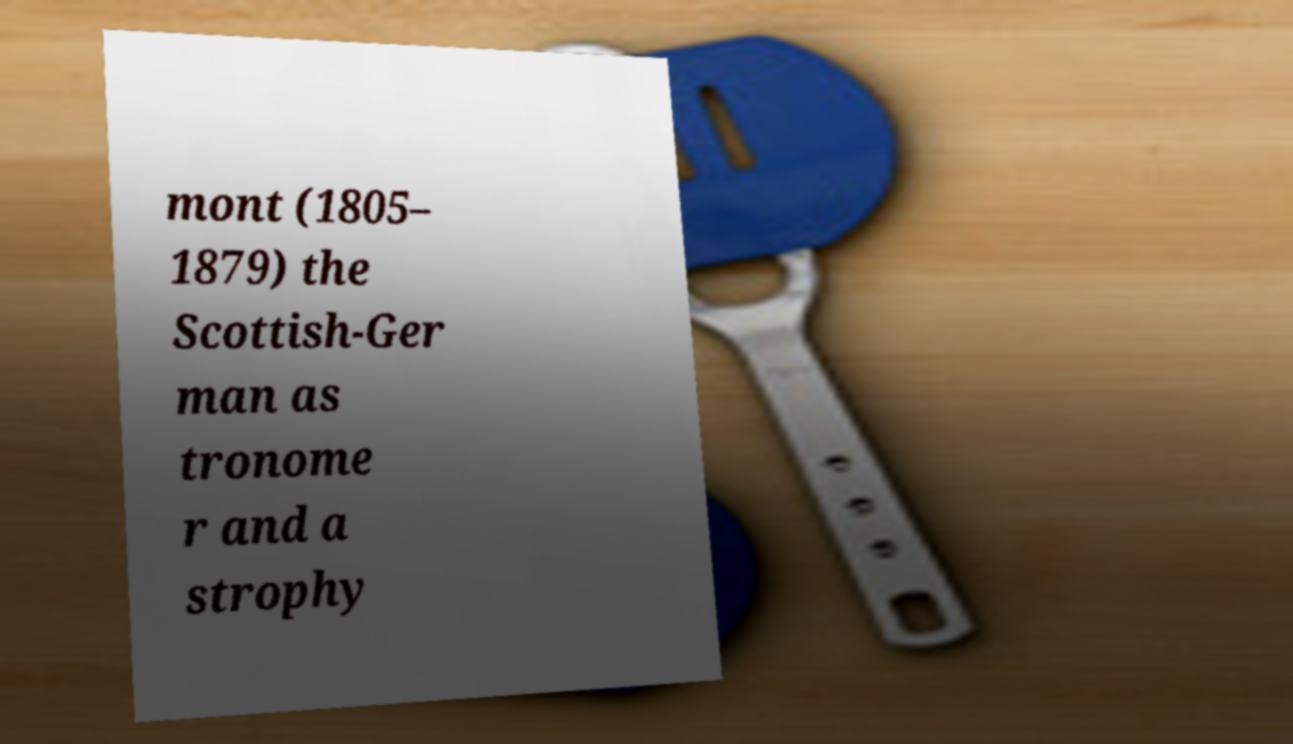Please read and relay the text visible in this image. What does it say? mont (1805– 1879) the Scottish-Ger man as tronome r and a strophy 